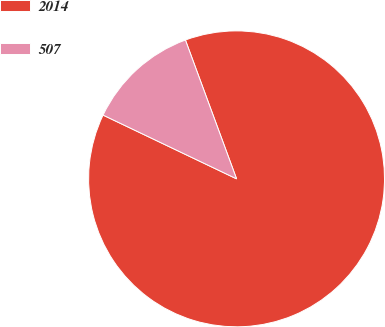Convert chart. <chart><loc_0><loc_0><loc_500><loc_500><pie_chart><fcel>2014<fcel>507<nl><fcel>87.71%<fcel>12.29%<nl></chart> 